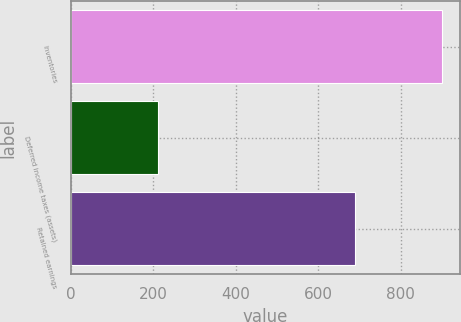<chart> <loc_0><loc_0><loc_500><loc_500><bar_chart><fcel>Inventories<fcel>Deferred income taxes (assets)<fcel>Retained earnings<nl><fcel>899<fcel>211<fcel>688<nl></chart> 